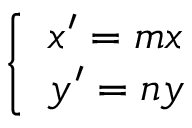<formula> <loc_0><loc_0><loc_500><loc_500>\left \{ \begin{array} { l l } { x ^ { \prime } = m x } \\ { y ^ { \prime } = n y } \end{array}</formula> 